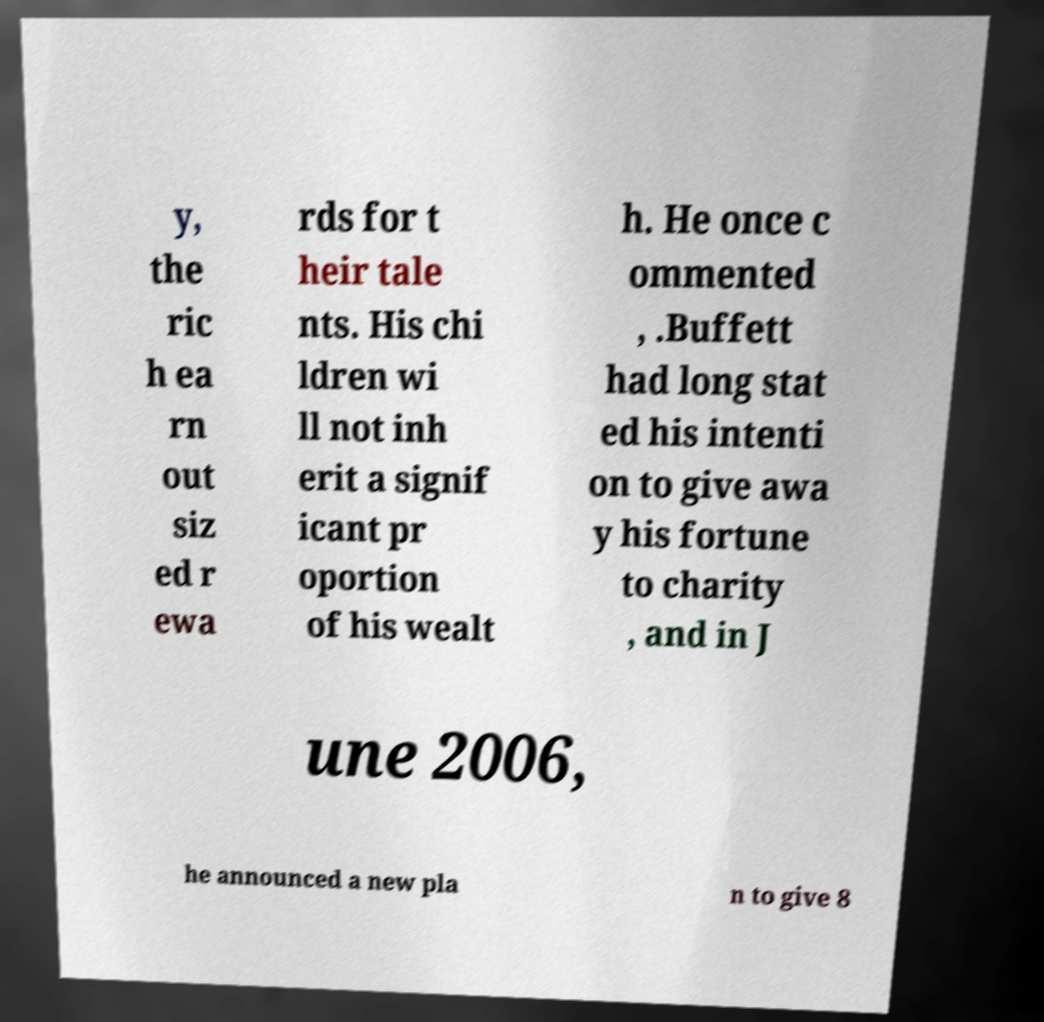Could you extract and type out the text from this image? y, the ric h ea rn out siz ed r ewa rds for t heir tale nts. His chi ldren wi ll not inh erit a signif icant pr oportion of his wealt h. He once c ommented , .Buffett had long stat ed his intenti on to give awa y his fortune to charity , and in J une 2006, he announced a new pla n to give 8 